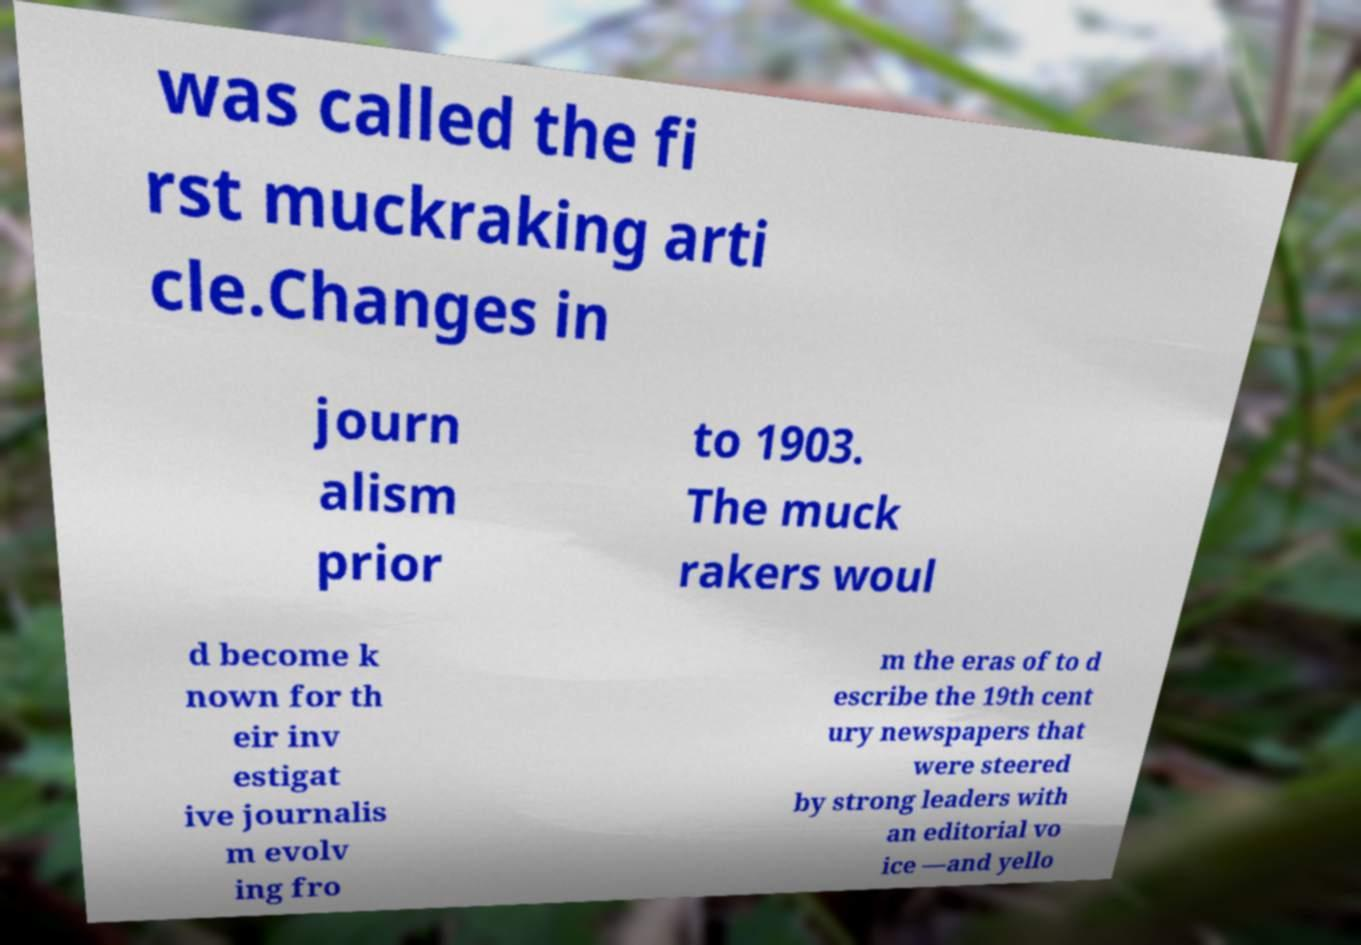Can you accurately transcribe the text from the provided image for me? was called the fi rst muckraking arti cle.Changes in journ alism prior to 1903. The muck rakers woul d become k nown for th eir inv estigat ive journalis m evolv ing fro m the eras of to d escribe the 19th cent ury newspapers that were steered by strong leaders with an editorial vo ice —and yello 